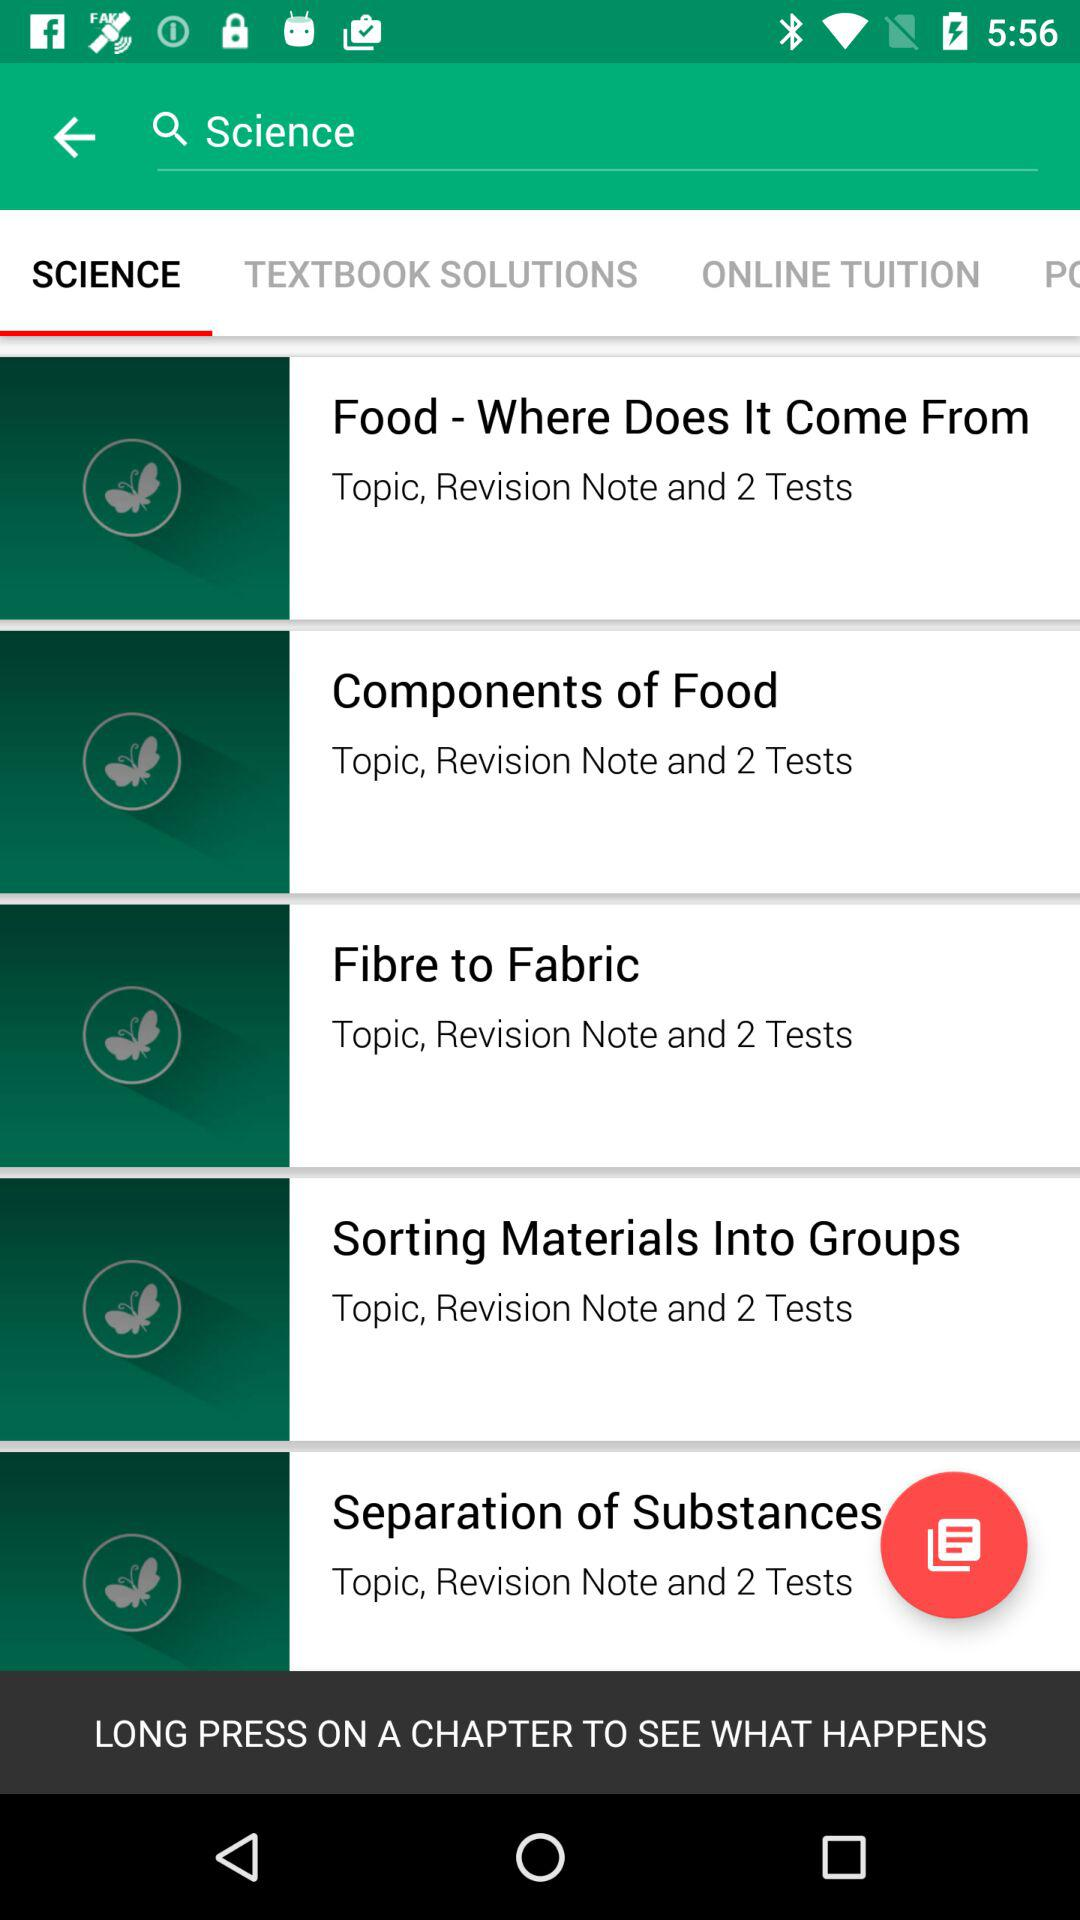What is the selected tab? The selected tab is "SCIENCE". 